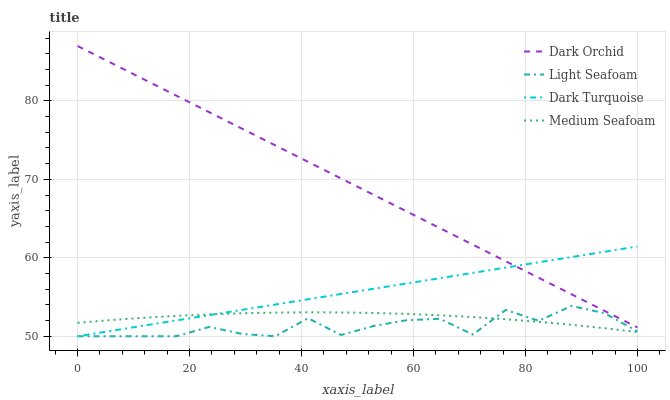Does Light Seafoam have the minimum area under the curve?
Answer yes or no. Yes. Does Dark Orchid have the maximum area under the curve?
Answer yes or no. Yes. Does Medium Seafoam have the minimum area under the curve?
Answer yes or no. No. Does Medium Seafoam have the maximum area under the curve?
Answer yes or no. No. Is Dark Turquoise the smoothest?
Answer yes or no. Yes. Is Light Seafoam the roughest?
Answer yes or no. Yes. Is Medium Seafoam the smoothest?
Answer yes or no. No. Is Medium Seafoam the roughest?
Answer yes or no. No. Does Dark Turquoise have the lowest value?
Answer yes or no. Yes. Does Medium Seafoam have the lowest value?
Answer yes or no. No. Does Dark Orchid have the highest value?
Answer yes or no. Yes. Does Light Seafoam have the highest value?
Answer yes or no. No. Is Light Seafoam less than Dark Orchid?
Answer yes or no. Yes. Is Dark Orchid greater than Medium Seafoam?
Answer yes or no. Yes. Does Light Seafoam intersect Medium Seafoam?
Answer yes or no. Yes. Is Light Seafoam less than Medium Seafoam?
Answer yes or no. No. Is Light Seafoam greater than Medium Seafoam?
Answer yes or no. No. Does Light Seafoam intersect Dark Orchid?
Answer yes or no. No. 